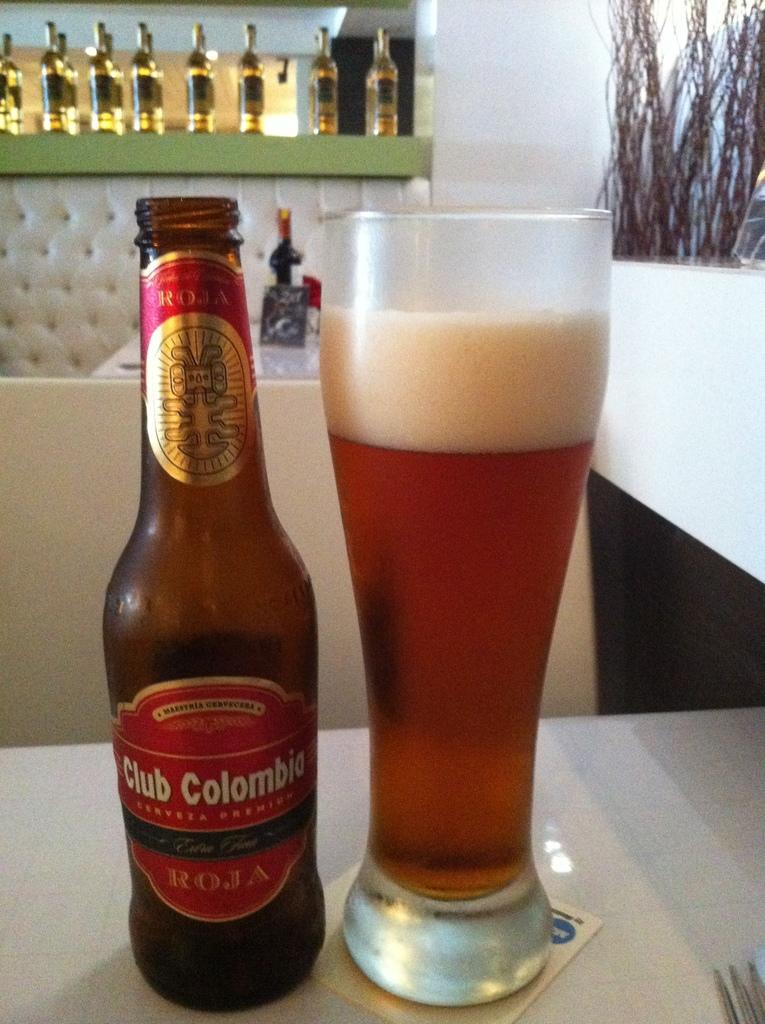<image>
Present a compact description of the photo's key features. A full glass and a bottle of Club Colombia beer 